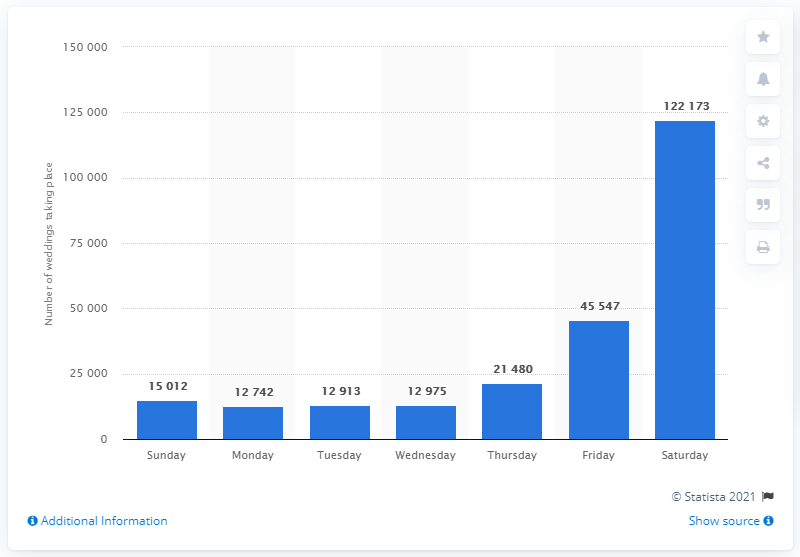Point out several critical features in this image. The most popular weekday for weddings in England and Wales in 2017 was Saturday. According to data from 2017, Friday was the second most popular day for weddings in England and Wales. 